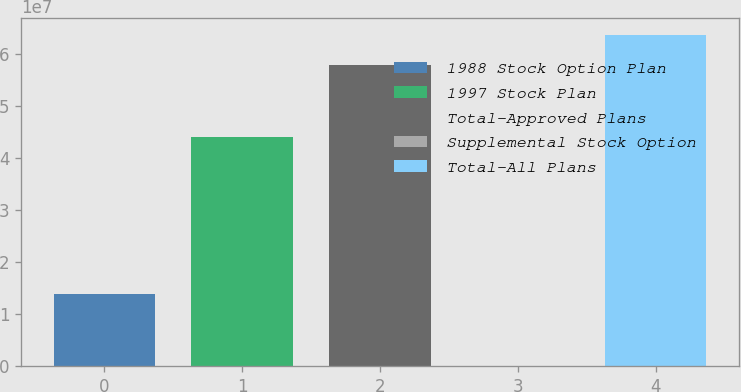Convert chart. <chart><loc_0><loc_0><loc_500><loc_500><bar_chart><fcel>1988 Stock Option Plan<fcel>1997 Stock Plan<fcel>Total-Approved Plans<fcel>Supplemental Stock Option<fcel>Total-All Plans<nl><fcel>1.3873e+07<fcel>4.39012e+07<fcel>5.77742e+07<fcel>6000<fcel>6.35516e+07<nl></chart> 